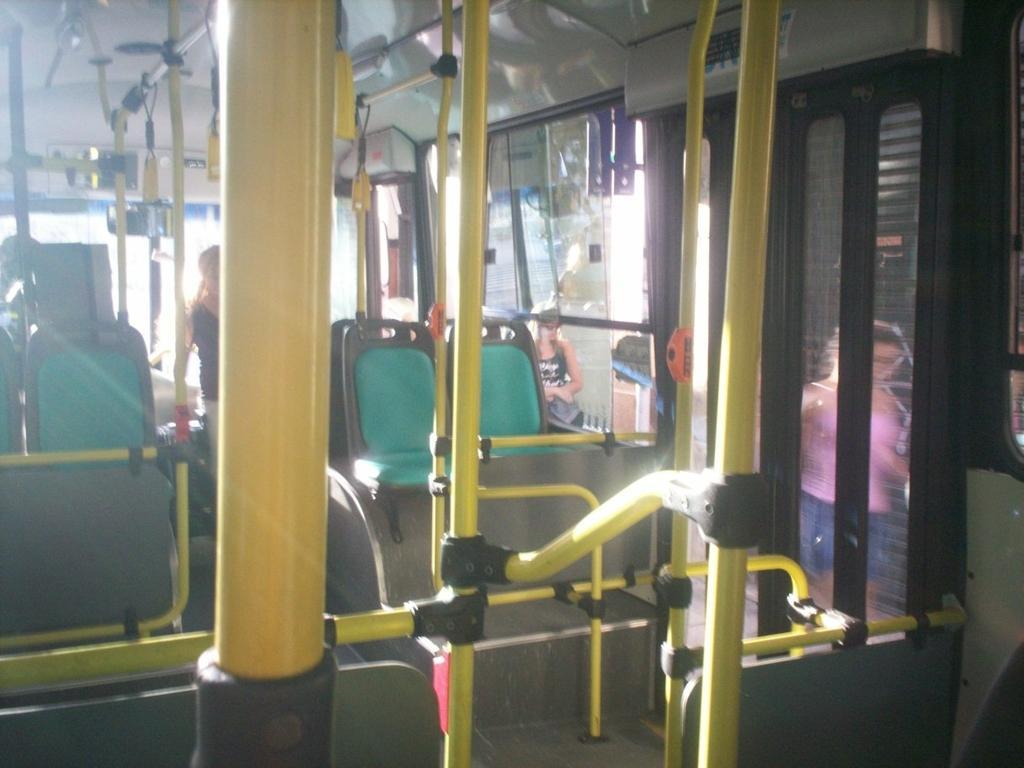Please provide a concise description of this image. In this picture I can see the seats and rods, it looks like an inside part of a bus, on the right side there are windows and a door, outside these windows I can see two women. 